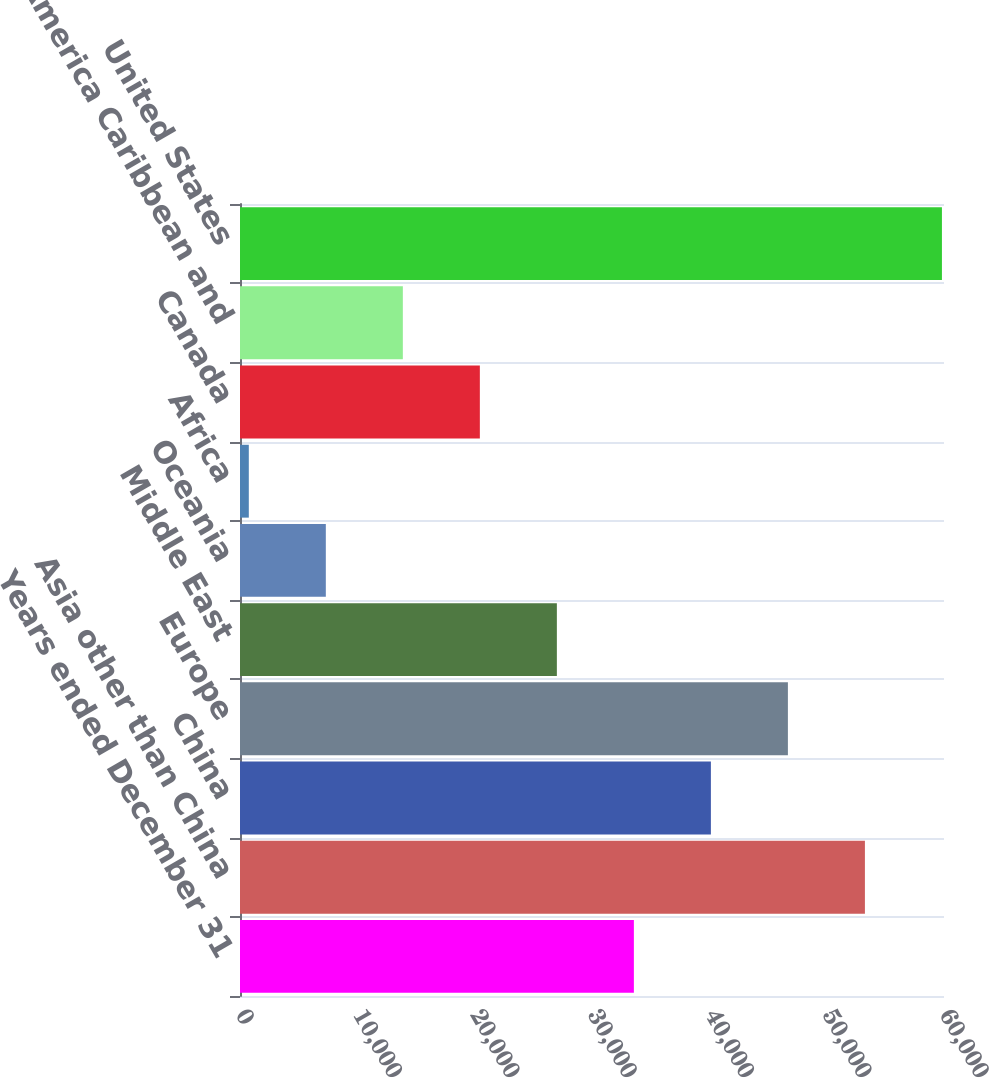<chart> <loc_0><loc_0><loc_500><loc_500><bar_chart><fcel>Years ended December 31<fcel>Asia other than China<fcel>China<fcel>Europe<fcel>Middle East<fcel>Oceania<fcel>Africa<fcel>Canada<fcel>Latin America Caribbean and<fcel>United States<nl><fcel>33569<fcel>53259.8<fcel>40132.6<fcel>46696.2<fcel>27005.4<fcel>7314.6<fcel>751<fcel>20441.8<fcel>13878.2<fcel>59823.4<nl></chart> 